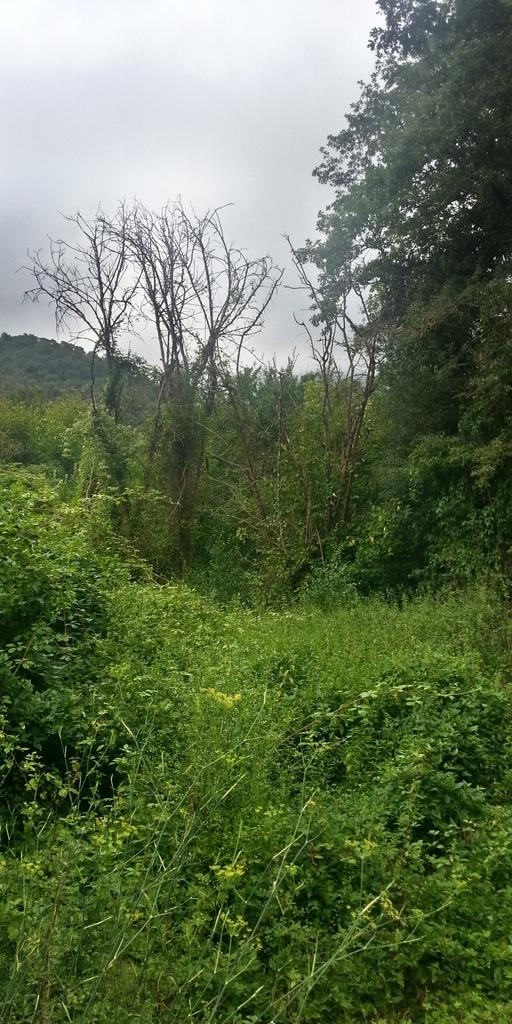What type of environment is shown in the image? The image depicts a forest. What are the main features of the forest? There are trees in the image. What can be seen in the sky in the image? There are clouds visible at the top of the image. What type of vegetation is present at the bottom of the image? There are plants at the bottom of the image. What is the opinion of the sun about the forest in the image? The image does not depict the sun, nor does it provide any information about the sun's opinion on the forest. 